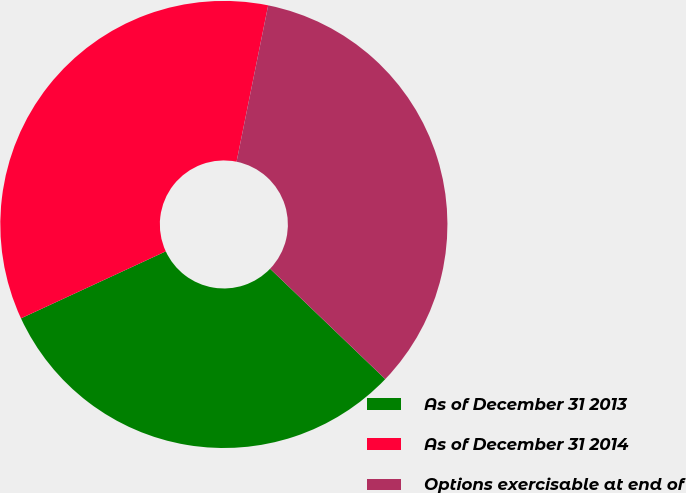<chart> <loc_0><loc_0><loc_500><loc_500><pie_chart><fcel>As of December 31 2013<fcel>As of December 31 2014<fcel>Options exercisable at end of<nl><fcel>30.94%<fcel>35.07%<fcel>33.98%<nl></chart> 